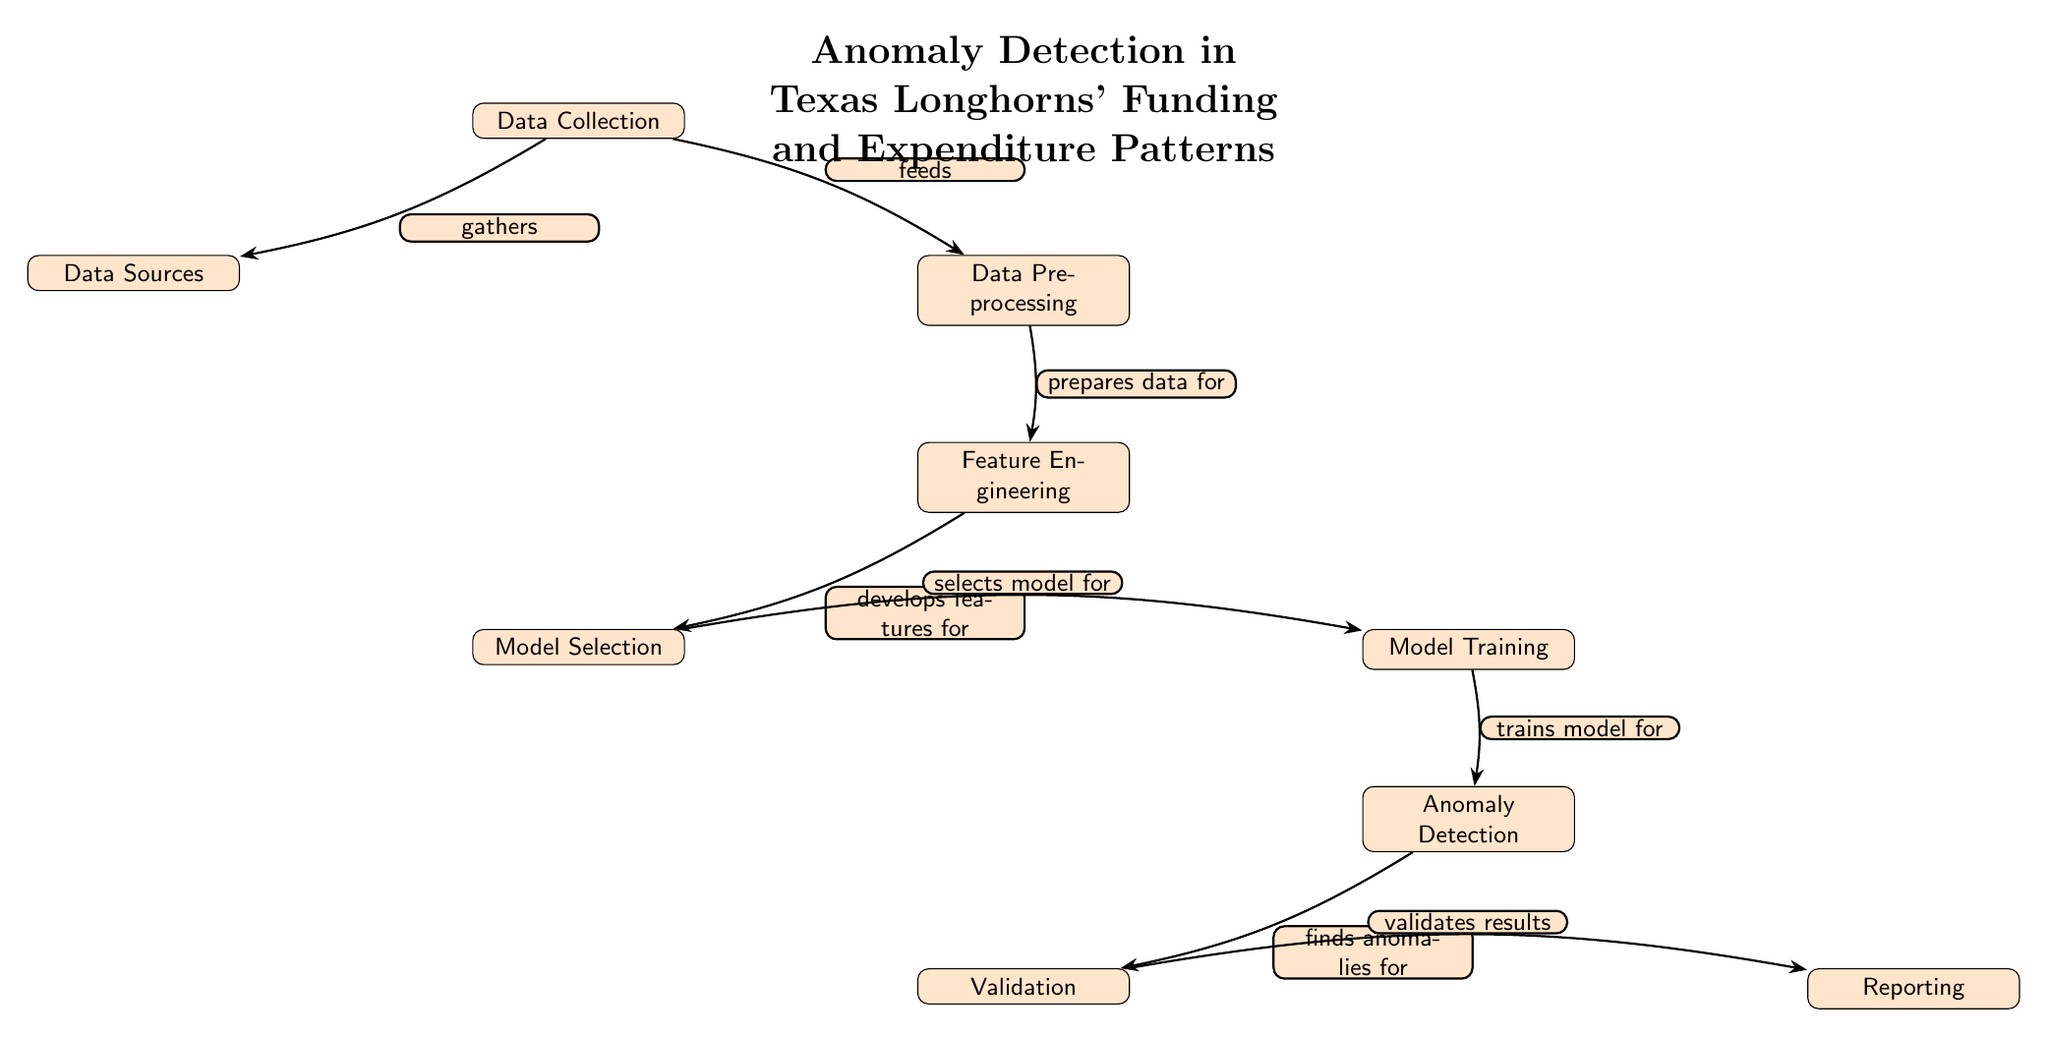What is the first step in the diagram? The diagram begins with the "Data Collection" node, which represents the first action taken in the anomaly detection process.
Answer: Data Collection How many nodes are present in the diagram? By counting all the distinct nodes in the diagram, there are a total of eight nodes.
Answer: Eight What is the function of the "Data Preprocessing" node? The "Data Preprocessing" node prepares the collected data for the next stage, which is feature engineering, indicating its role as a preparatory step.
Answer: Prepares data for Which node follows "Model Training" in the flow? The next node after "Model Training" is "Anomaly Detection," which indicates that the model is used to find anomalies in the funding and expenditure patterns.
Answer: Anomaly Detection What is the output of the "Anomaly Detection" node? The "Anomaly Detection" node leads to the "Validation" node, signifying that the outcomes from anomaly detection are validated in this step.
Answer: Validation What relationship exists between "Feature Engineering" and "Model Selection"? "Feature Engineering" develops features that are crucial for the "Model Selection," indicating a preparatory relationship between these two nodes.
Answer: Develops features for Which node receives data from "Data Collection"? "Data Preprocessing" directly receives data from "Data Collection" to begin preparing the data for further analysis.
Answer: Data Preprocessing What does the "Validation" node validate? The "Validation" node validates the results obtained from the "Anomaly Detection" process, ensuring the accuracy of identified anomalies.
Answer: Validates results Which step occurs before "Reporting"? The step that occurs prior to "Reporting" is "Validation," where the findings are confirmed before presentation.
Answer: Validation 